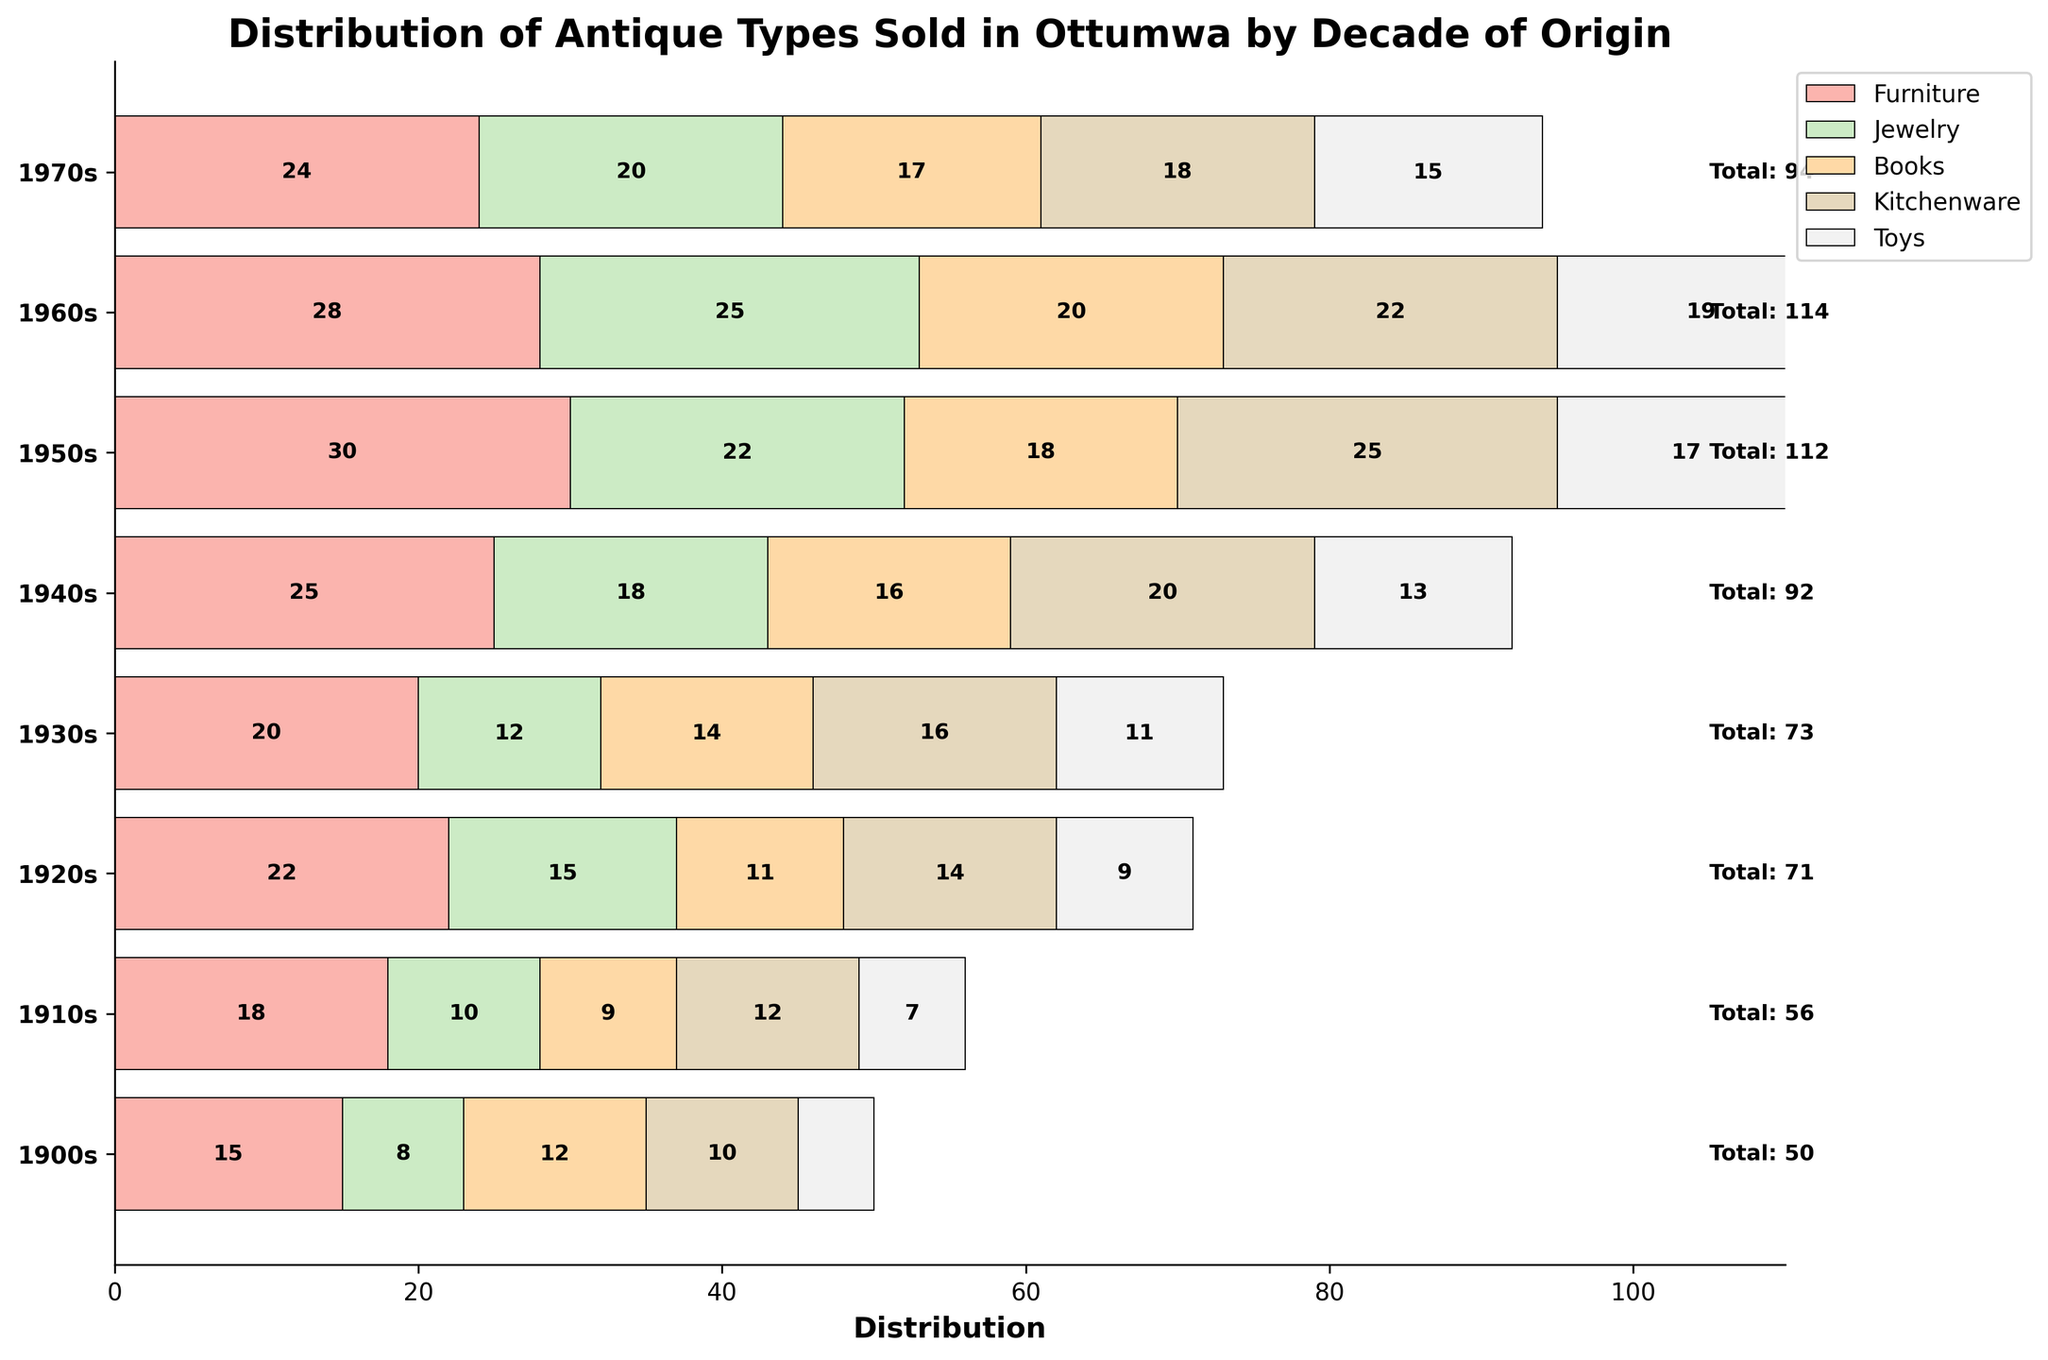What's the title of the figure? The title is displayed at the top of the figure. It reads, "Distribution of Antique Types Sold in Ottumwa by Decade of Origin."
Answer: Distribution of Antique Types Sold in Ottumwa by Decade of Origin Which category of antiques has the highest distribution in the 1930s? By looking at the bars representing different categories for the 1930s, the category with the largest segment is Kitchenware.
Answer: Kitchenware How many furniture antiques were sold in the 1900s? The bar for Furniture in the 1900s segment shows a width of 15.
Answer: 15 What is the total number of antiques sold in the 1970s? The total number for each decade is written to the right of each decade label. For the 1970s, it says Total: 94.
Answer: 94 Which decade saw the highest number of books sold? By examining the segments for Books across all decades, the highest number appears to be in the 1960s with a count of 20.
Answer: 1960s What is the combined number of Jewelry and Toys sold in the 1940s? The number of Jewelry sold in the 1940s is 18, and the number of Toys is 13. Adding these together: 18 + 13 = 31.
Answer: 31 Which decade had fewer Kitchenware sales, the 1900s or the 1910s? By comparing the Kitchenware segments, the 1900s had 10 sales, whereas the 1910s had 12 sales. Therefore, the 1900s had fewer sales.
Answer: 1900s How does the distribution of Toys in the 1950s compare to the 1970s? The segment for Toys in the 1950s shows 17, while for the 1970s it shows 15. Thus, the 1950s had more Toy sales than the 1970s.
Answer: 1950s Which category shows the overall increase over decades? Observing trends over decades for each category, Furniture shows a general increase from the 1900s (15) to its peak in the 1950s (30) before slightly declining.
Answer: Furniture 